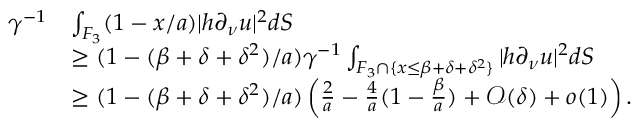<formula> <loc_0><loc_0><loc_500><loc_500>\begin{array} { r l } { \gamma ^ { - 1 } } & { \int _ { F _ { 3 } } ( 1 - x / a ) | h \partial _ { \nu } u | ^ { 2 } d S } \\ & { \geq ( 1 - ( \beta + \delta + \delta ^ { 2 } ) / a ) \gamma ^ { - 1 } \int _ { F _ { 3 } \cap \{ x \leq \beta + \delta + \delta ^ { 2 } \} } | h \partial _ { \nu } u | ^ { 2 } d S } \\ & { \geq ( 1 - ( \beta + \delta + \delta ^ { 2 } ) / a ) \left ( \frac { 2 } { a } - \frac { 4 } { a } ( 1 - \frac { \beta } { a } ) + { \mathcal { O } } ( \delta ) + o ( 1 ) \right ) . } \end{array}</formula> 